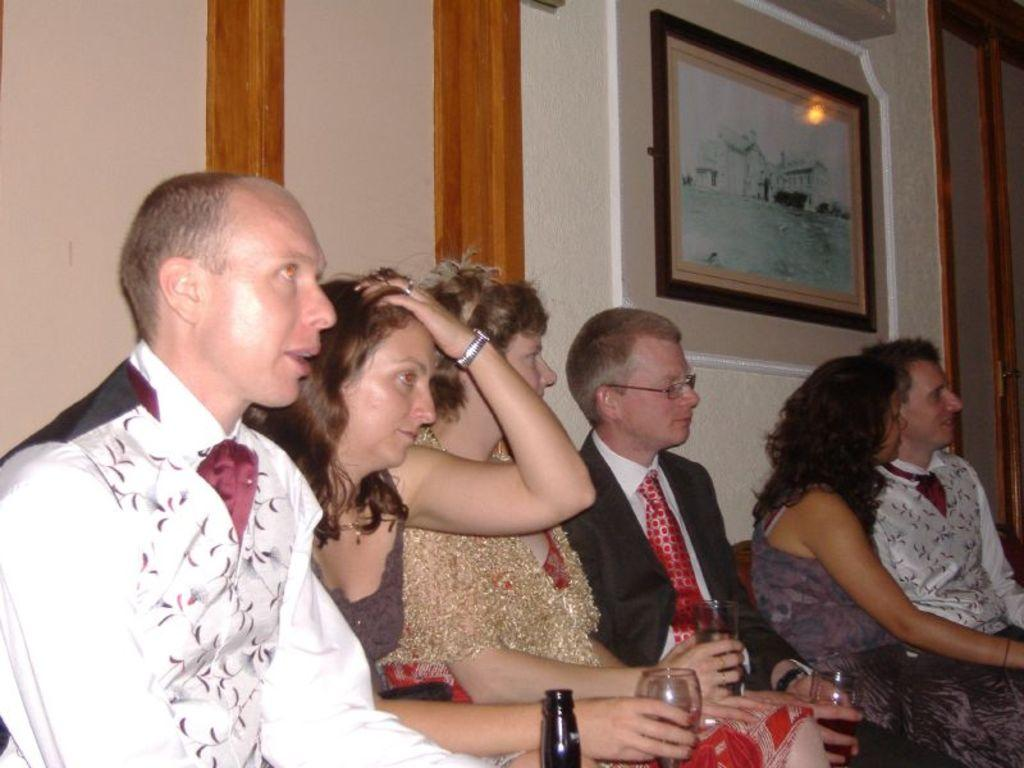How many people are in the group in the image? There is a group of people in the image, but the exact number is not specified. What are some people in the group doing in the image? Some people in the group are holding objects in their hands. What can be seen on the wall in the image? There is a wall in the image, and there is a photo on the wall. What type of fear can be seen on the faces of the people in the image? There is no indication of fear on the faces of the people in the image. What type of plough is being used by the people in the image? There is no plough present in the image. 